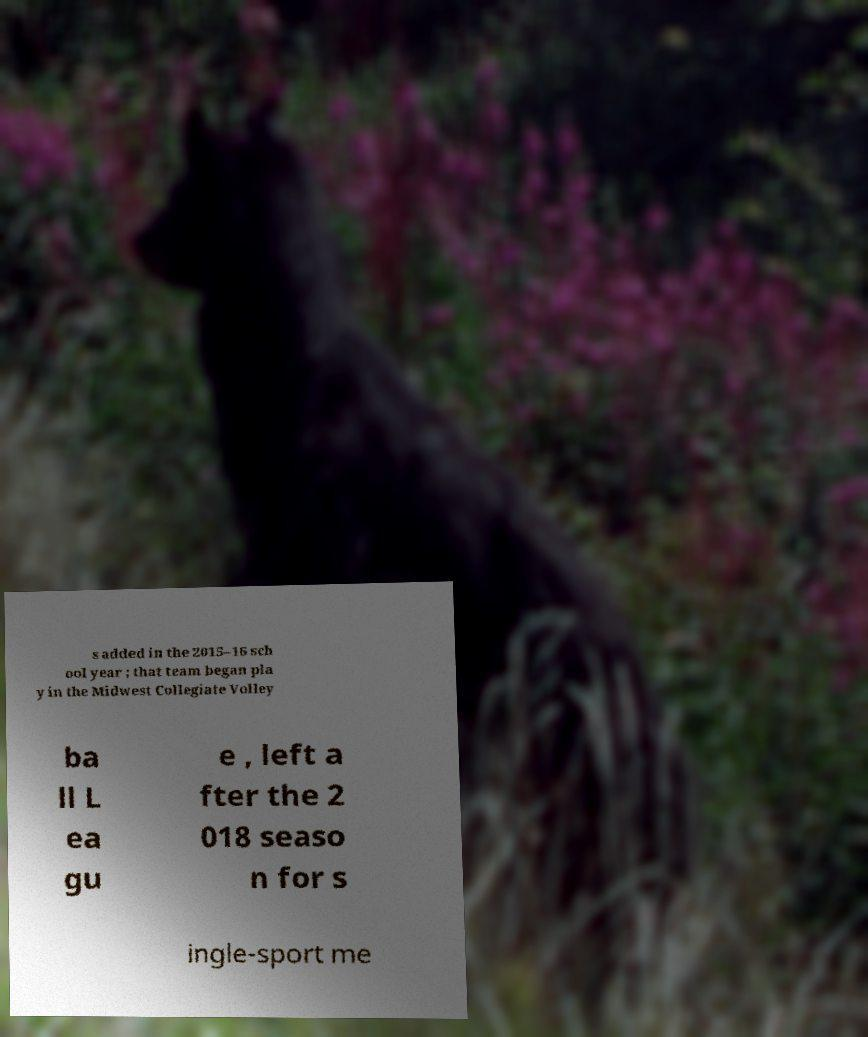Could you assist in decoding the text presented in this image and type it out clearly? s added in the 2015–16 sch ool year ; that team began pla y in the Midwest Collegiate Volley ba ll L ea gu e , left a fter the 2 018 seaso n for s ingle-sport me 